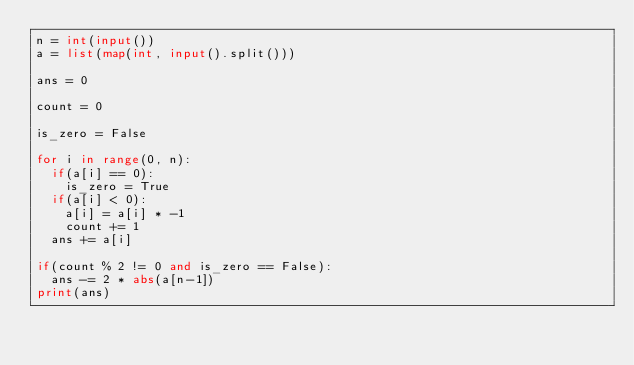<code> <loc_0><loc_0><loc_500><loc_500><_Python_>n = int(input())
a = list(map(int, input().split()))

ans = 0

count = 0

is_zero = False

for i in range(0, n):
	if(a[i] == 0):
		is_zero = True
	if(a[i] < 0):
		a[i] = a[i] * -1
		count += 1
	ans += a[i]

if(count % 2 != 0 and is_zero == False):
	ans -= 2 * abs(a[n-1])
print(ans)</code> 